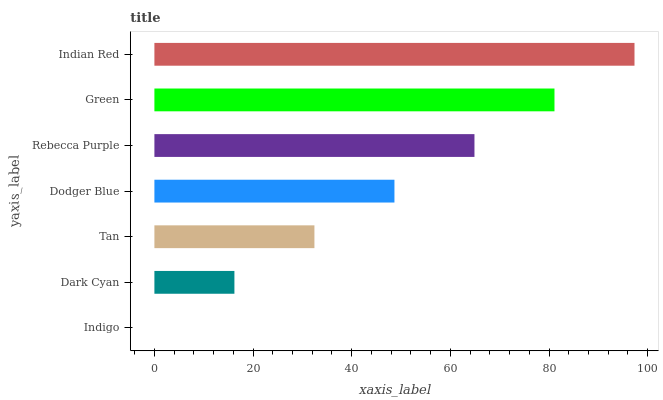Is Indigo the minimum?
Answer yes or no. Yes. Is Indian Red the maximum?
Answer yes or no. Yes. Is Dark Cyan the minimum?
Answer yes or no. No. Is Dark Cyan the maximum?
Answer yes or no. No. Is Dark Cyan greater than Indigo?
Answer yes or no. Yes. Is Indigo less than Dark Cyan?
Answer yes or no. Yes. Is Indigo greater than Dark Cyan?
Answer yes or no. No. Is Dark Cyan less than Indigo?
Answer yes or no. No. Is Dodger Blue the high median?
Answer yes or no. Yes. Is Dodger Blue the low median?
Answer yes or no. Yes. Is Tan the high median?
Answer yes or no. No. Is Green the low median?
Answer yes or no. No. 